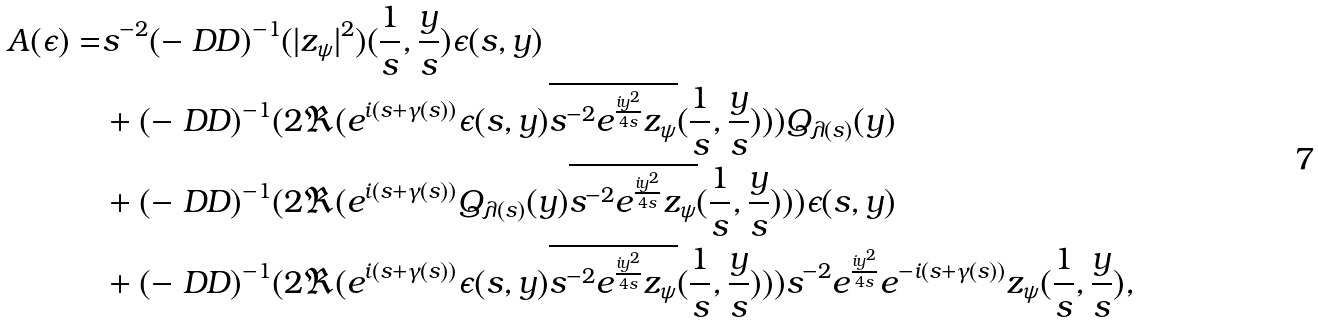<formula> <loc_0><loc_0><loc_500><loc_500>A ( \epsilon ) = & s ^ { - 2 } ( - \ D D ) ^ { - 1 } ( | z _ { \psi } | ^ { 2 } ) ( \frac { 1 } { s } , \frac { y } { s } ) \epsilon ( s , y ) \\ & + ( - \ D D ) ^ { - 1 } ( 2 \Re ( e ^ { i ( s + \gamma ( s ) ) } \epsilon ( s , y ) \overline { s ^ { - 2 } e ^ { \frac { i y ^ { 2 } } { 4 s } } z _ { \psi } } ( \frac { 1 } { s } , \frac { y } { s } ) ) ) Q _ { \lambda ( s ) } ( y ) \\ & + ( - \ D D ) ^ { - 1 } ( 2 \Re ( e ^ { i ( s + \gamma ( s ) ) } Q _ { \lambda ( s ) } ( y ) \overline { s ^ { - 2 } e ^ { \frac { i y ^ { 2 } } { 4 s } } z _ { \psi } } ( \frac { 1 } { s } , \frac { y } { s } ) ) ) \epsilon ( s , y ) \\ & + ( - \ D D ) ^ { - 1 } ( 2 \Re ( e ^ { i ( s + \gamma ( s ) ) } \epsilon ( s , y ) \overline { s ^ { - 2 } e ^ { \frac { i y ^ { 2 } } { 4 s } } z _ { \psi } } ( \frac { 1 } { s } , \frac { y } { s } ) ) ) s ^ { - 2 } e ^ { \frac { i y ^ { 2 } } { 4 s } } e ^ { - i ( s + \gamma ( s ) ) } z _ { \psi } ( \frac { 1 } { s } , \frac { y } { s } ) ,</formula> 